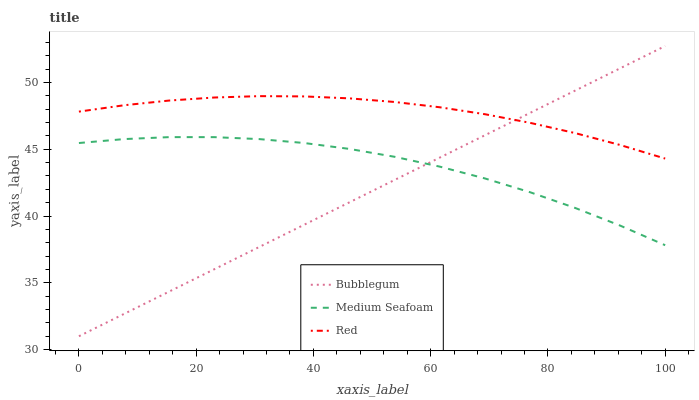Does Bubblegum have the minimum area under the curve?
Answer yes or no. Yes. Does Red have the maximum area under the curve?
Answer yes or no. Yes. Does Medium Seafoam have the minimum area under the curve?
Answer yes or no. No. Does Medium Seafoam have the maximum area under the curve?
Answer yes or no. No. Is Bubblegum the smoothest?
Answer yes or no. Yes. Is Medium Seafoam the roughest?
Answer yes or no. Yes. Is Medium Seafoam the smoothest?
Answer yes or no. No. Is Bubblegum the roughest?
Answer yes or no. No. Does Medium Seafoam have the lowest value?
Answer yes or no. No. Does Bubblegum have the highest value?
Answer yes or no. Yes. Does Medium Seafoam have the highest value?
Answer yes or no. No. Is Medium Seafoam less than Red?
Answer yes or no. Yes. Is Red greater than Medium Seafoam?
Answer yes or no. Yes. Does Medium Seafoam intersect Bubblegum?
Answer yes or no. Yes. Is Medium Seafoam less than Bubblegum?
Answer yes or no. No. Is Medium Seafoam greater than Bubblegum?
Answer yes or no. No. Does Medium Seafoam intersect Red?
Answer yes or no. No. 